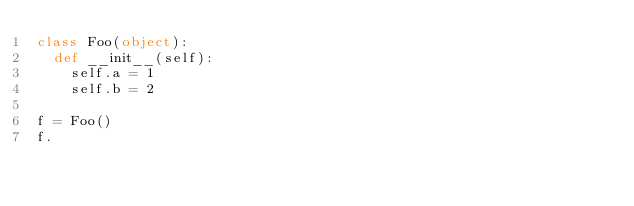Convert code to text. <code><loc_0><loc_0><loc_500><loc_500><_Python_>class Foo(object):
  def __init__(self):
    self.a = 1
    self.b = 2

f = Foo()
f.
</code> 